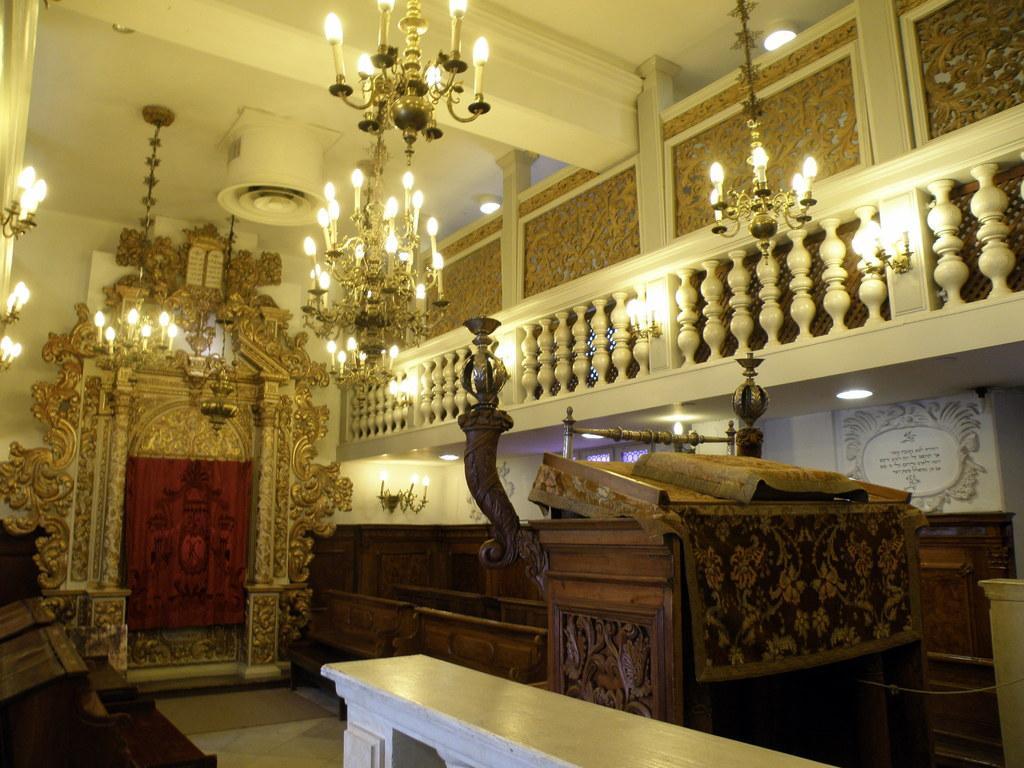Can you describe this image briefly? In the center of the image there is a wall, roof, fence, board with some text, wooden objects, chandeliers and a few other objects. And we can see some design on the wall. 